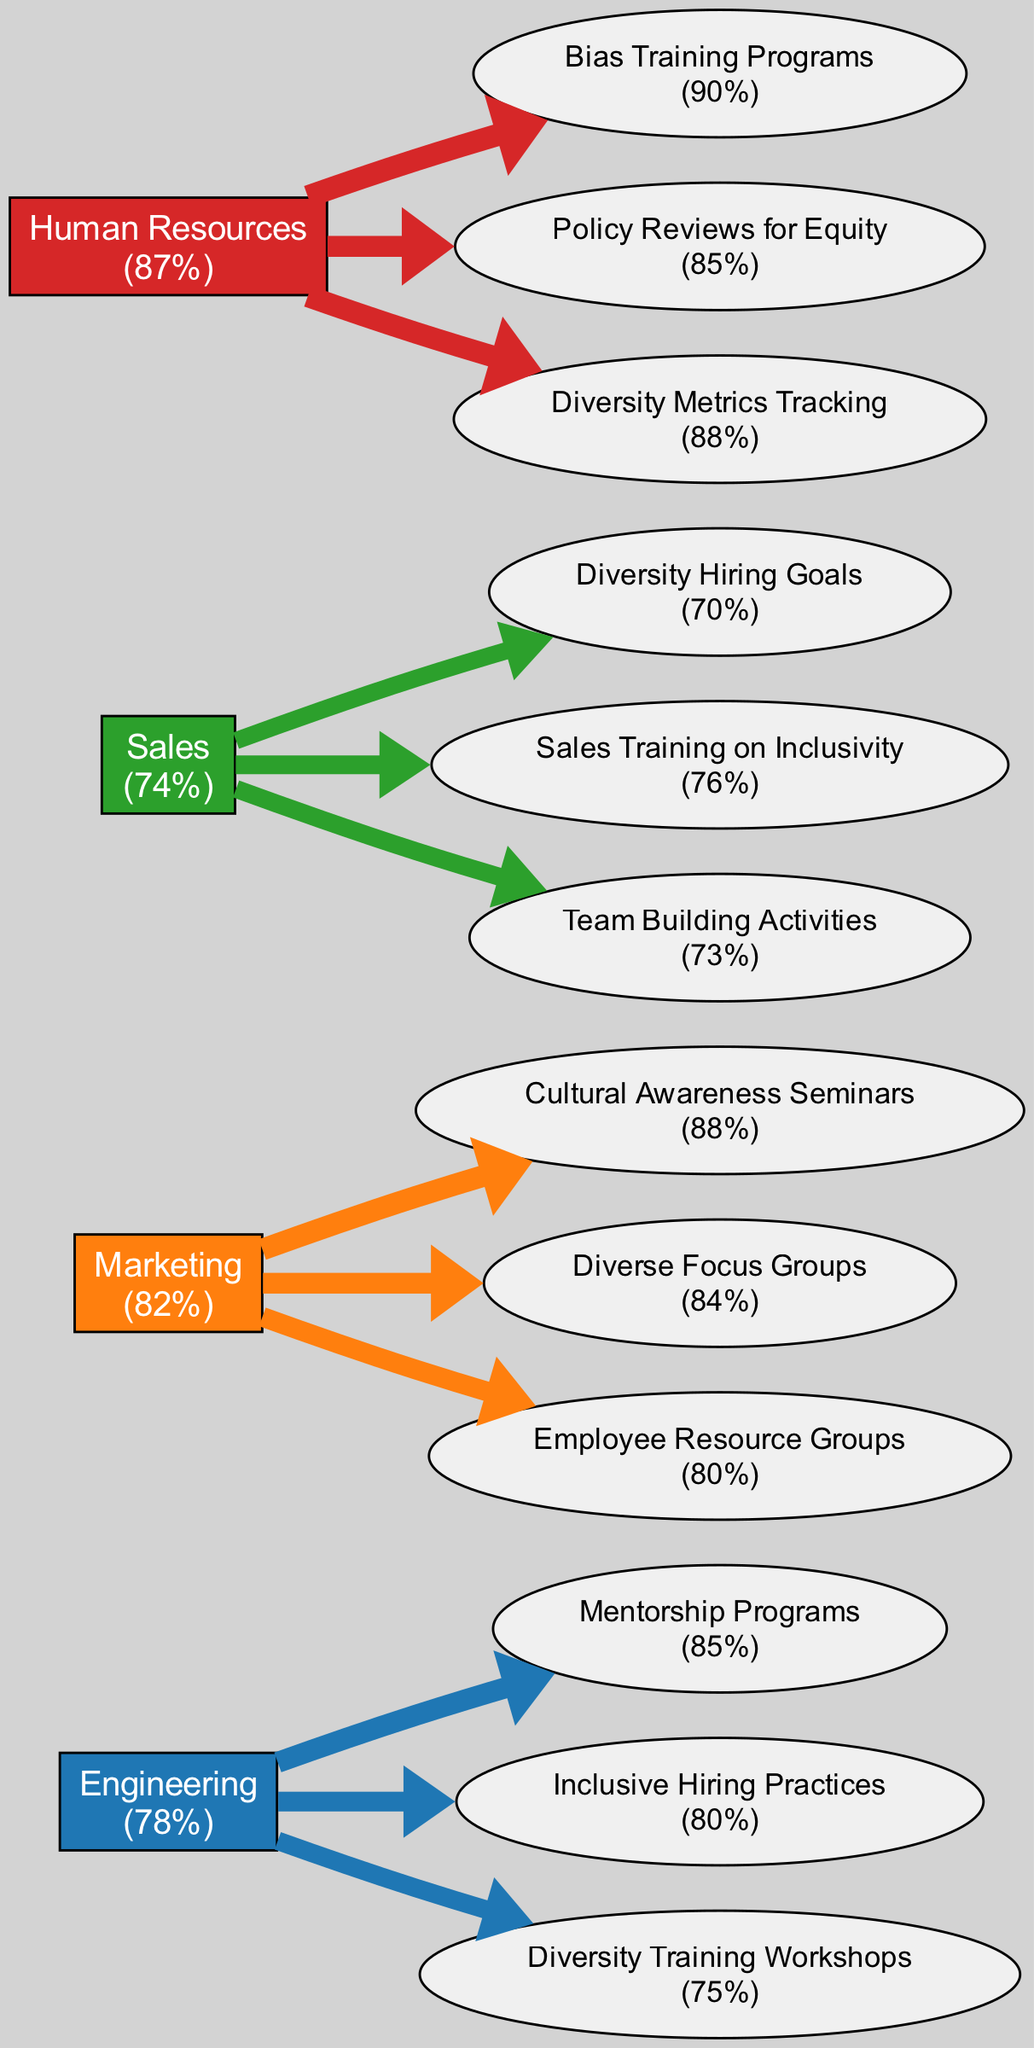What is the satisfaction score for the Human Resources department? The diagram indicates that the Human Resources department has a satisfaction score displayed next to its node. The figure shows "87%" below the department's name.
Answer: 87% Which diversity initiative in the Engineering department received the highest score? By examining the initiative nodes connected to the Engineering department, "Mentorship Programs" has a score of 85%, which is higher than the other initiatives listed.
Answer: Mentorship Programs How many diversity initiatives are listed for the Sales department? The diagram shows the Sales department node connected to three initiative nodes. Each initiative corresponds to a different training or hiring practice, indicating a total of three initiatives.
Answer: 3 What is the average satisfaction score across all departments? To find the average, sum the satisfaction scores of all departments: (78 + 82 + 74 + 87) = 321. Then divide by the number of departments (4). The result is 321 / 4 = 80.25%.
Answer: 80.25% Which department has the lowest satisfaction score and what is that score? The Sales department is shown with the lowest value of 74% next to its node, making it easy to identify it visually.
Answer: Sales, 74% How does the satisfaction score in Marketing compare to that in Engineering? By comparing the satisfaction nodes of Marketing (82%) and Engineering (78%), it can be determined that Marketing has a higher score by a difference of 4%.
Answer: Marketing, 82% Which initiative in the Human Resources department is closest to the maximum score of 90%? Reviewing the initiatives for the Human Resources department reveals "Bias Training Programs" with a score of 90%, making it the closest to the maximum within that department.
Answer: Bias Training Programs Which department has the initiative with the lowest score and what is that score? By checking all the initiatives across departments, "Diversity Hiring Goals" in the Sales department is seen with the score of 70%, which is lower than all other initiatives.
Answer: Sales, 70% 